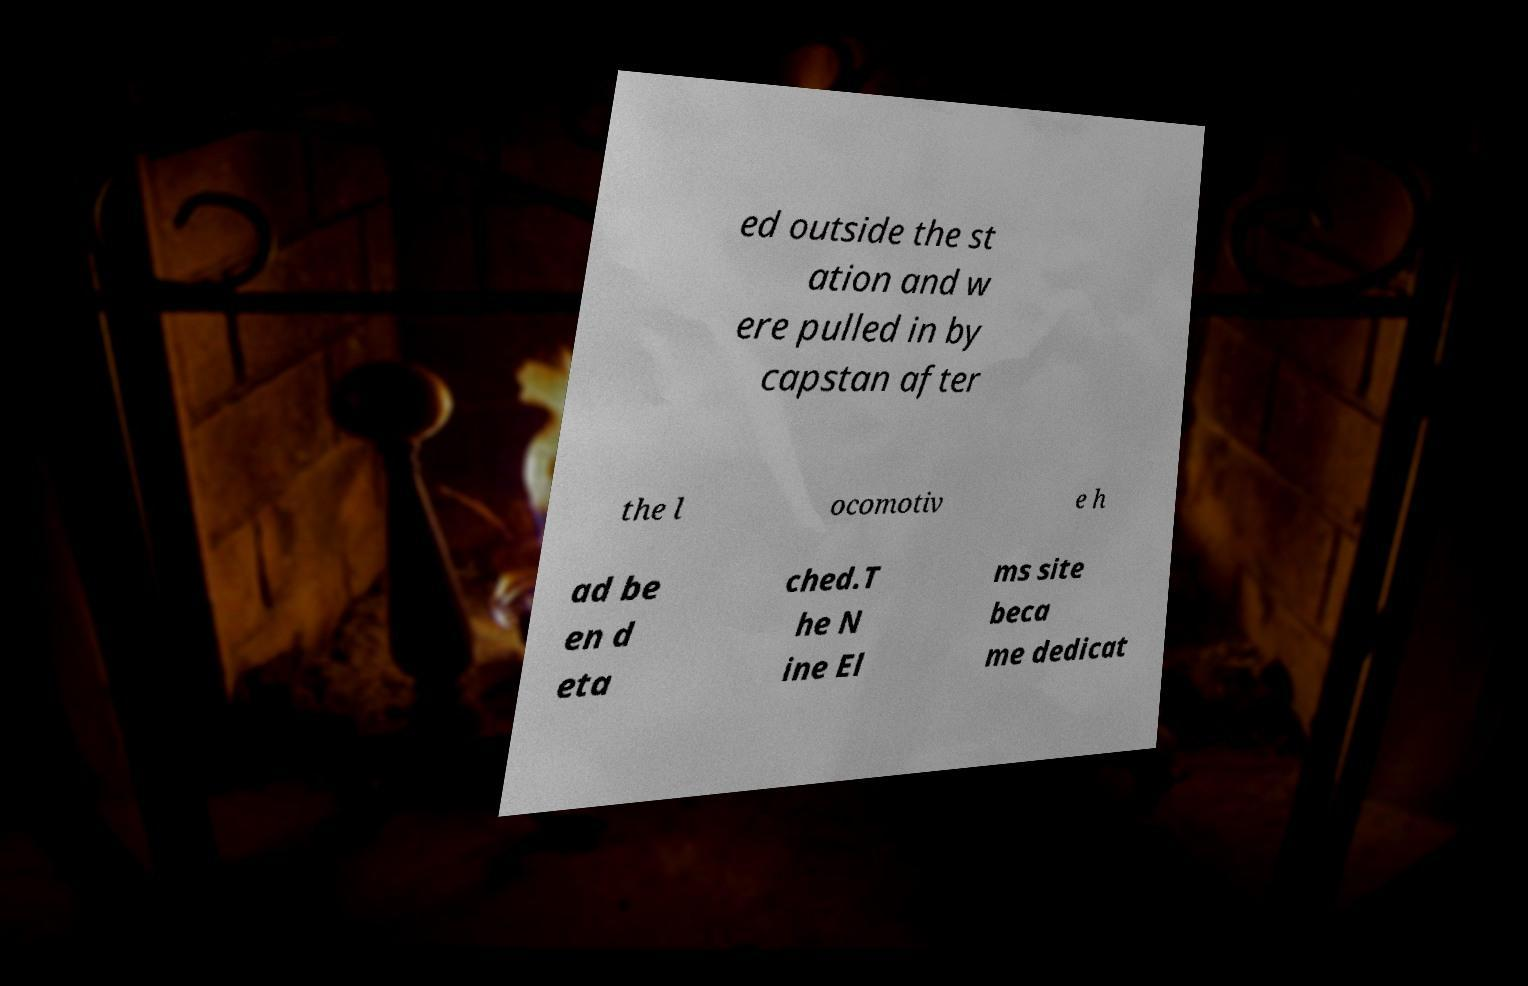For documentation purposes, I need the text within this image transcribed. Could you provide that? ed outside the st ation and w ere pulled in by capstan after the l ocomotiv e h ad be en d eta ched.T he N ine El ms site beca me dedicat 